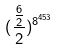Convert formula to latex. <formula><loc_0><loc_0><loc_500><loc_500>( \frac { \frac { 6 } { 2 } } { 2 } ) ^ { 8 ^ { 4 5 3 } }</formula> 